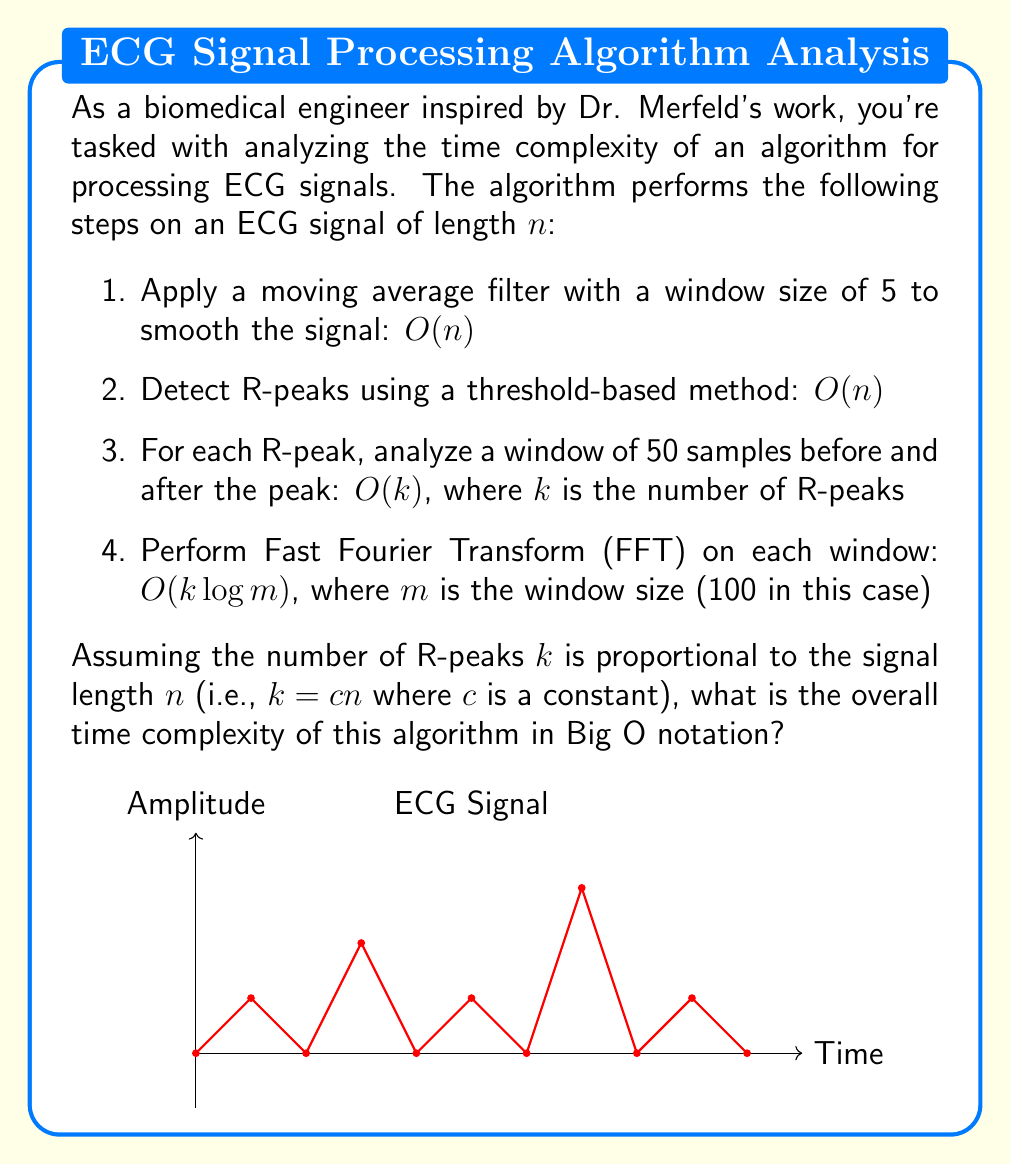Give your solution to this math problem. Let's analyze the time complexity of each step and then combine them to get the overall complexity:

1. Moving average filter: $O(n)$
   This step processes each sample once, so it's linear in the signal length.

2. R-peak detection: $O(n)$
   This also processes each sample once, so it's linear.

3. Windowing around R-peaks: $O(k)$ where $k$ is the number of R-peaks
   We're given that $k = cn$ where $c$ is a constant, so this step is actually $O(n)$

4. FFT on each window: $O(k \log m)$ where $m$ is the window size (100)
   Since $k = cn$ and $m$ is constant (100), this becomes $O(n \log 100)$

Now, let's combine these steps:

$$O(n) + O(n) + O(n) + O(n \log 100)$$

The dominant term here is $O(n \log 100)$. However, since 100 is a constant, $\log 100$ is also a constant. In Big O notation, we can simplify this to:

$$O(n)$$

This is because the constant factor $\log 100$ doesn't affect the asymptotic growth rate as $n$ increases.
Answer: $O(n)$ 